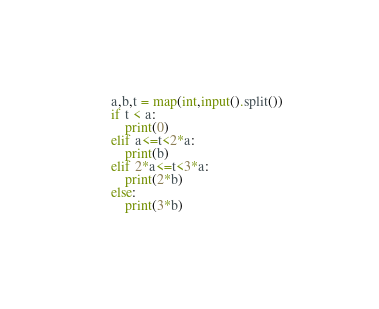Convert code to text. <code><loc_0><loc_0><loc_500><loc_500><_Python_>a,b,t = map(int,input().split())
if t < a:
    print(0)
elif a<=t<2*a:
    print(b)
elif 2*a<=t<3*a:
    print(2*b) 
else:
    print(3*b)</code> 